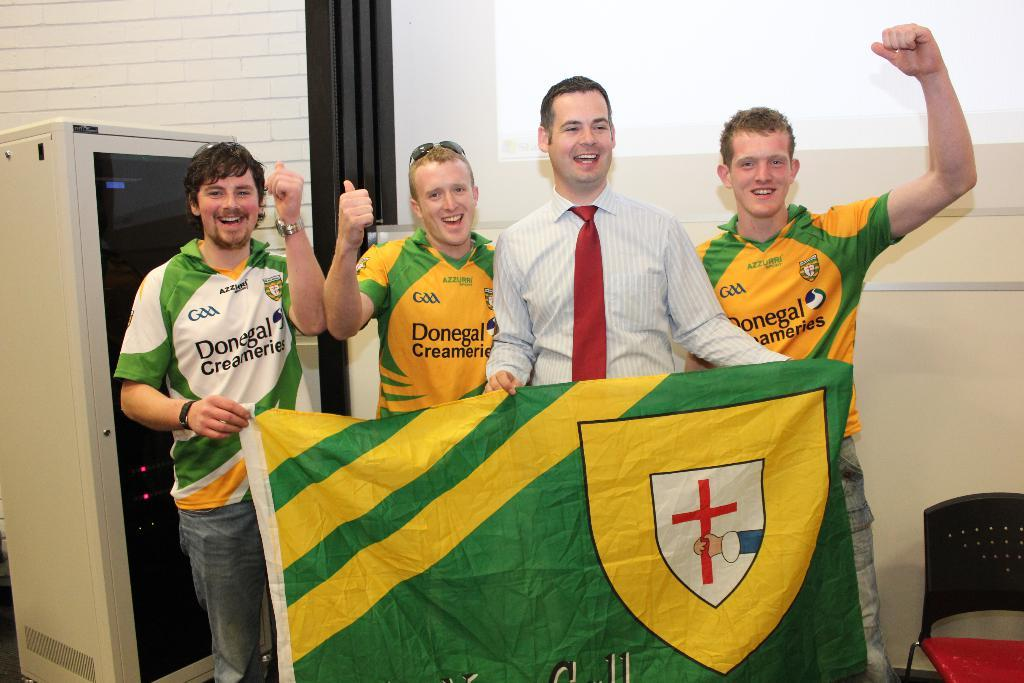<image>
Create a compact narrative representing the image presented. a person with a Donegal shirt standing with others 